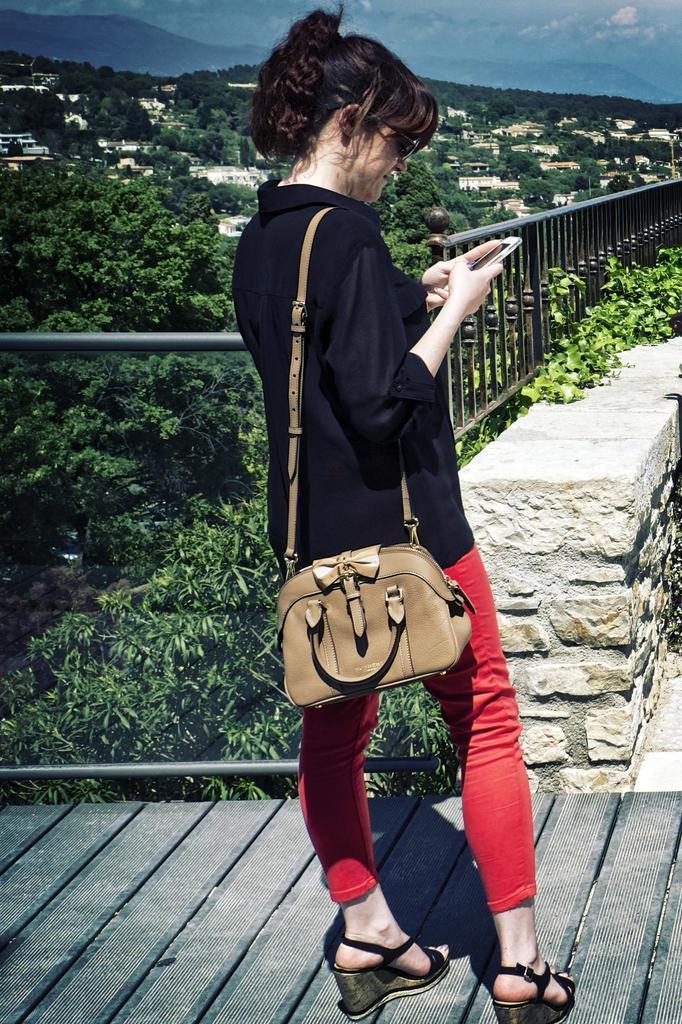Could you give a brief overview of what you see in this image? This person standing and holding mobile and wear bag. On the background we can see trees,houses,sky,fence. 